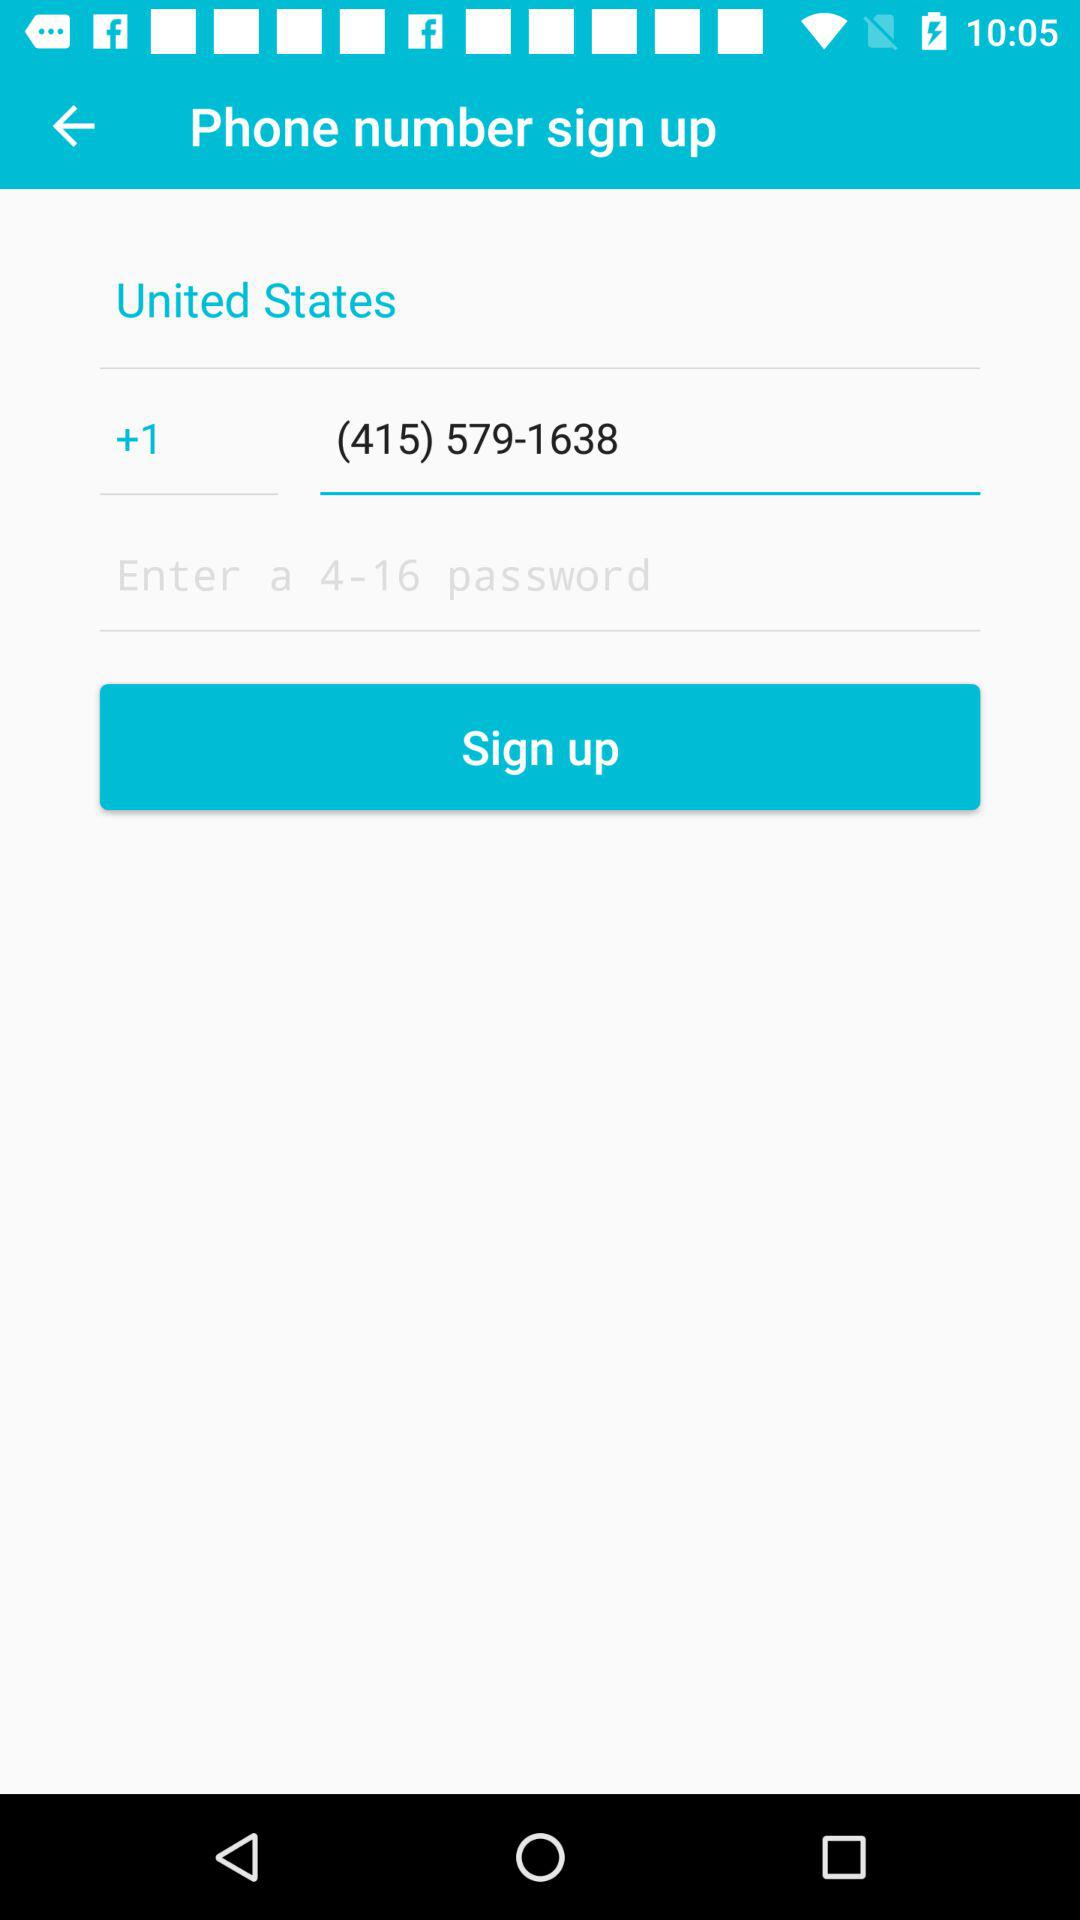What country's phone number is given? The country's phone number is +1 (415) 579-1638. 